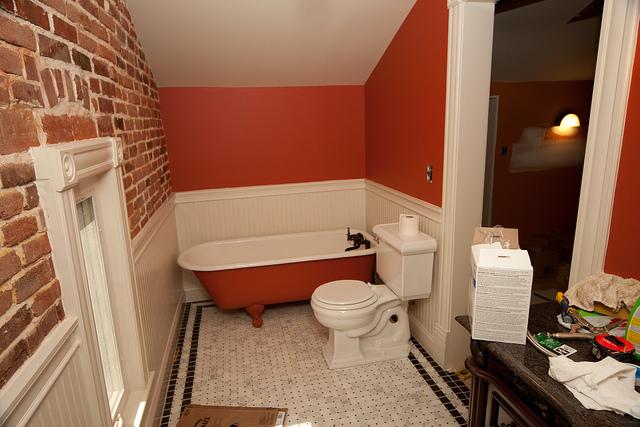What part of the room is the bathtub painted to match?
Quick response, please. Wall. Are they out of toilet paper?
Give a very brief answer. No. What material is on the walls?
Give a very brief answer. Brick. 